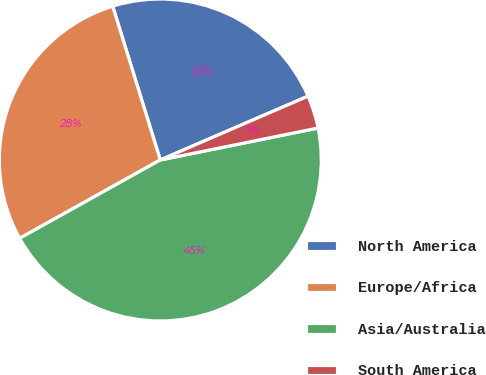Convert chart. <chart><loc_0><loc_0><loc_500><loc_500><pie_chart><fcel>North America<fcel>Europe/Africa<fcel>Asia/Australia<fcel>South America<nl><fcel>23.29%<fcel>28.31%<fcel>45.09%<fcel>3.31%<nl></chart> 